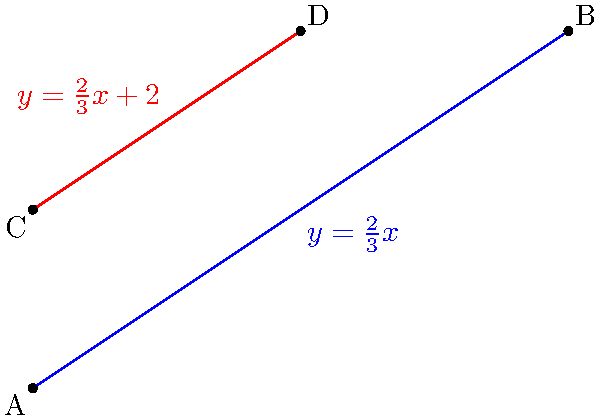In the coordinate plane above, two lines are shown: a blue line passing through points A(0,0) and B(6,4), and a red line passing through points C(0,2) and D(3,4). Determine if these lines are parallel, perpendicular, or neither. Justify your answer using the slopes of the lines. Let's approach this step-by-step:

1) First, we need to calculate the slopes of both lines.

2) For the blue line (AB):
   Slope = $\frac{y_2 - y_1}{x_2 - x_1} = \frac{4 - 0}{6 - 0} = \frac{4}{6} = \frac{2}{3}$

3) For the red line (CD):
   Slope = $\frac{y_2 - y_1}{x_2 - x_1} = \frac{4 - 2}{3 - 0} = \frac{2}{3}$

4) We can see that both lines have the same slope: $\frac{2}{3}$

5) Remember:
   - Parallel lines have the same slope
   - Perpendicular lines have slopes that are negative reciprocals of each other
   - If lines are neither parallel nor perpendicular, they have different slopes that are not negative reciprocals

6) Since both lines have the same slope ($\frac{2}{3}$), they are parallel.

7) We can also observe this visually in the graph, as the lines never intersect and maintain the same distance from each other.
Answer: The lines are parallel. 